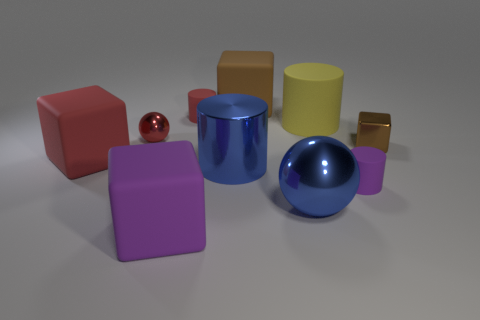Is the color of the big metal ball the same as the metallic cylinder?
Keep it short and to the point. Yes. What material is the large object that is the same color as the large ball?
Your answer should be compact. Metal. How many other things are there of the same color as the tiny metal sphere?
Ensure brevity in your answer.  2. The big cylinder that is in front of the rubber block that is left of the big purple rubber cube is made of what material?
Give a very brief answer. Metal. What number of other things are the same material as the tiny ball?
Give a very brief answer. 3. What is the material of the cube that is the same size as the red matte cylinder?
Offer a terse response. Metal. Are there more small purple things to the left of the purple block than brown rubber objects in front of the small red ball?
Make the answer very short. No. Is there a purple rubber object of the same shape as the large red matte object?
Ensure brevity in your answer.  Yes. What shape is the purple matte thing that is the same size as the shiny block?
Your answer should be very brief. Cylinder. There is a brown thing that is to the right of the big rubber cylinder; what is its shape?
Offer a very short reply. Cube. 